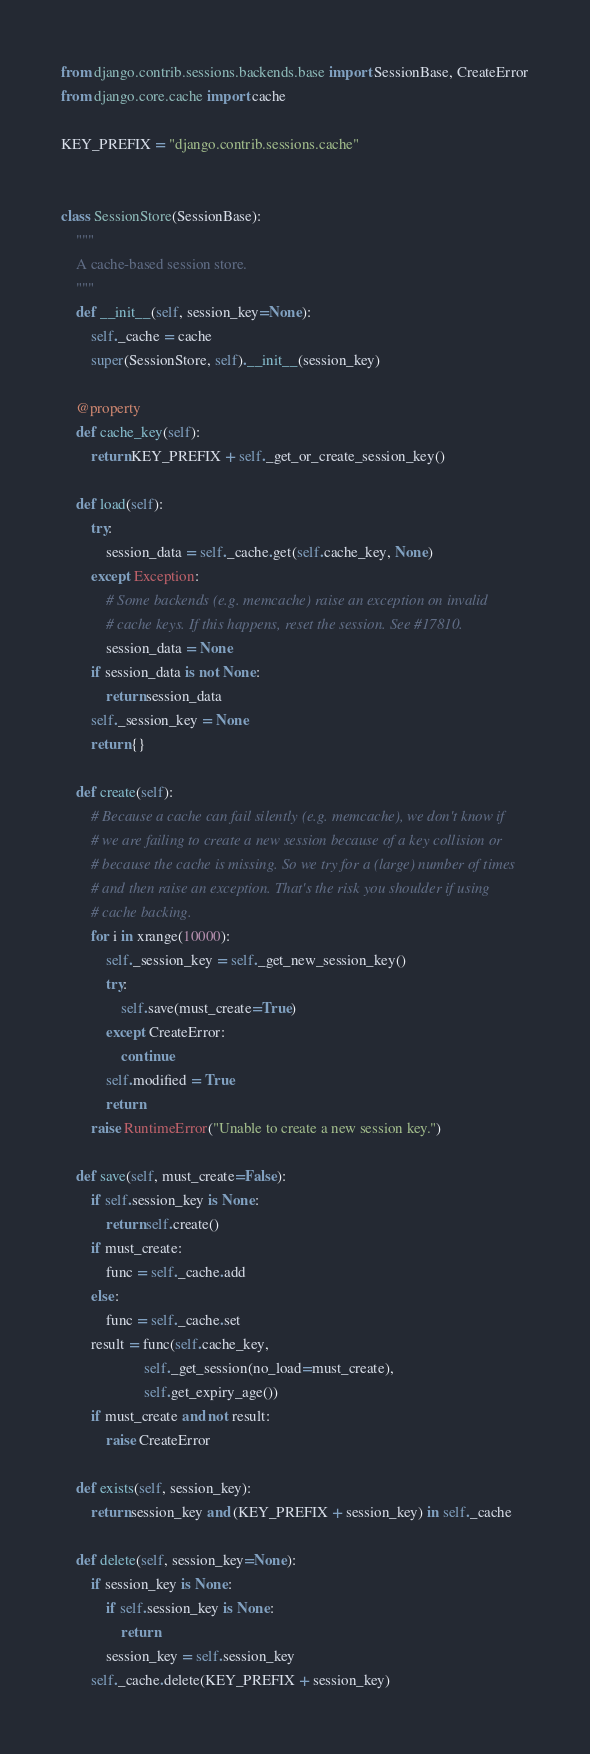<code> <loc_0><loc_0><loc_500><loc_500><_Python_>from django.contrib.sessions.backends.base import SessionBase, CreateError
from django.core.cache import cache

KEY_PREFIX = "django.contrib.sessions.cache"


class SessionStore(SessionBase):
    """
    A cache-based session store.
    """
    def __init__(self, session_key=None):
        self._cache = cache
        super(SessionStore, self).__init__(session_key)

    @property
    def cache_key(self):
        return KEY_PREFIX + self._get_or_create_session_key()

    def load(self):
        try:
            session_data = self._cache.get(self.cache_key, None)
        except Exception:
            # Some backends (e.g. memcache) raise an exception on invalid
            # cache keys. If this happens, reset the session. See #17810.
            session_data = None
        if session_data is not None:
            return session_data
        self._session_key = None
        return {}

    def create(self):
        # Because a cache can fail silently (e.g. memcache), we don't know if
        # we are failing to create a new session because of a key collision or
        # because the cache is missing. So we try for a (large) number of times
        # and then raise an exception. That's the risk you shoulder if using
        # cache backing.
        for i in xrange(10000):
            self._session_key = self._get_new_session_key()
            try:
                self.save(must_create=True)
            except CreateError:
                continue
            self.modified = True
            return
        raise RuntimeError("Unable to create a new session key.")

    def save(self, must_create=False):
        if self.session_key is None:
            return self.create()
        if must_create:
            func = self._cache.add
        else:
            func = self._cache.set
        result = func(self.cache_key,
                      self._get_session(no_load=must_create),
                      self.get_expiry_age())
        if must_create and not result:
            raise CreateError

    def exists(self, session_key):
        return session_key and (KEY_PREFIX + session_key) in self._cache

    def delete(self, session_key=None):
        if session_key is None:
            if self.session_key is None:
                return
            session_key = self.session_key
        self._cache.delete(KEY_PREFIX + session_key)
</code> 